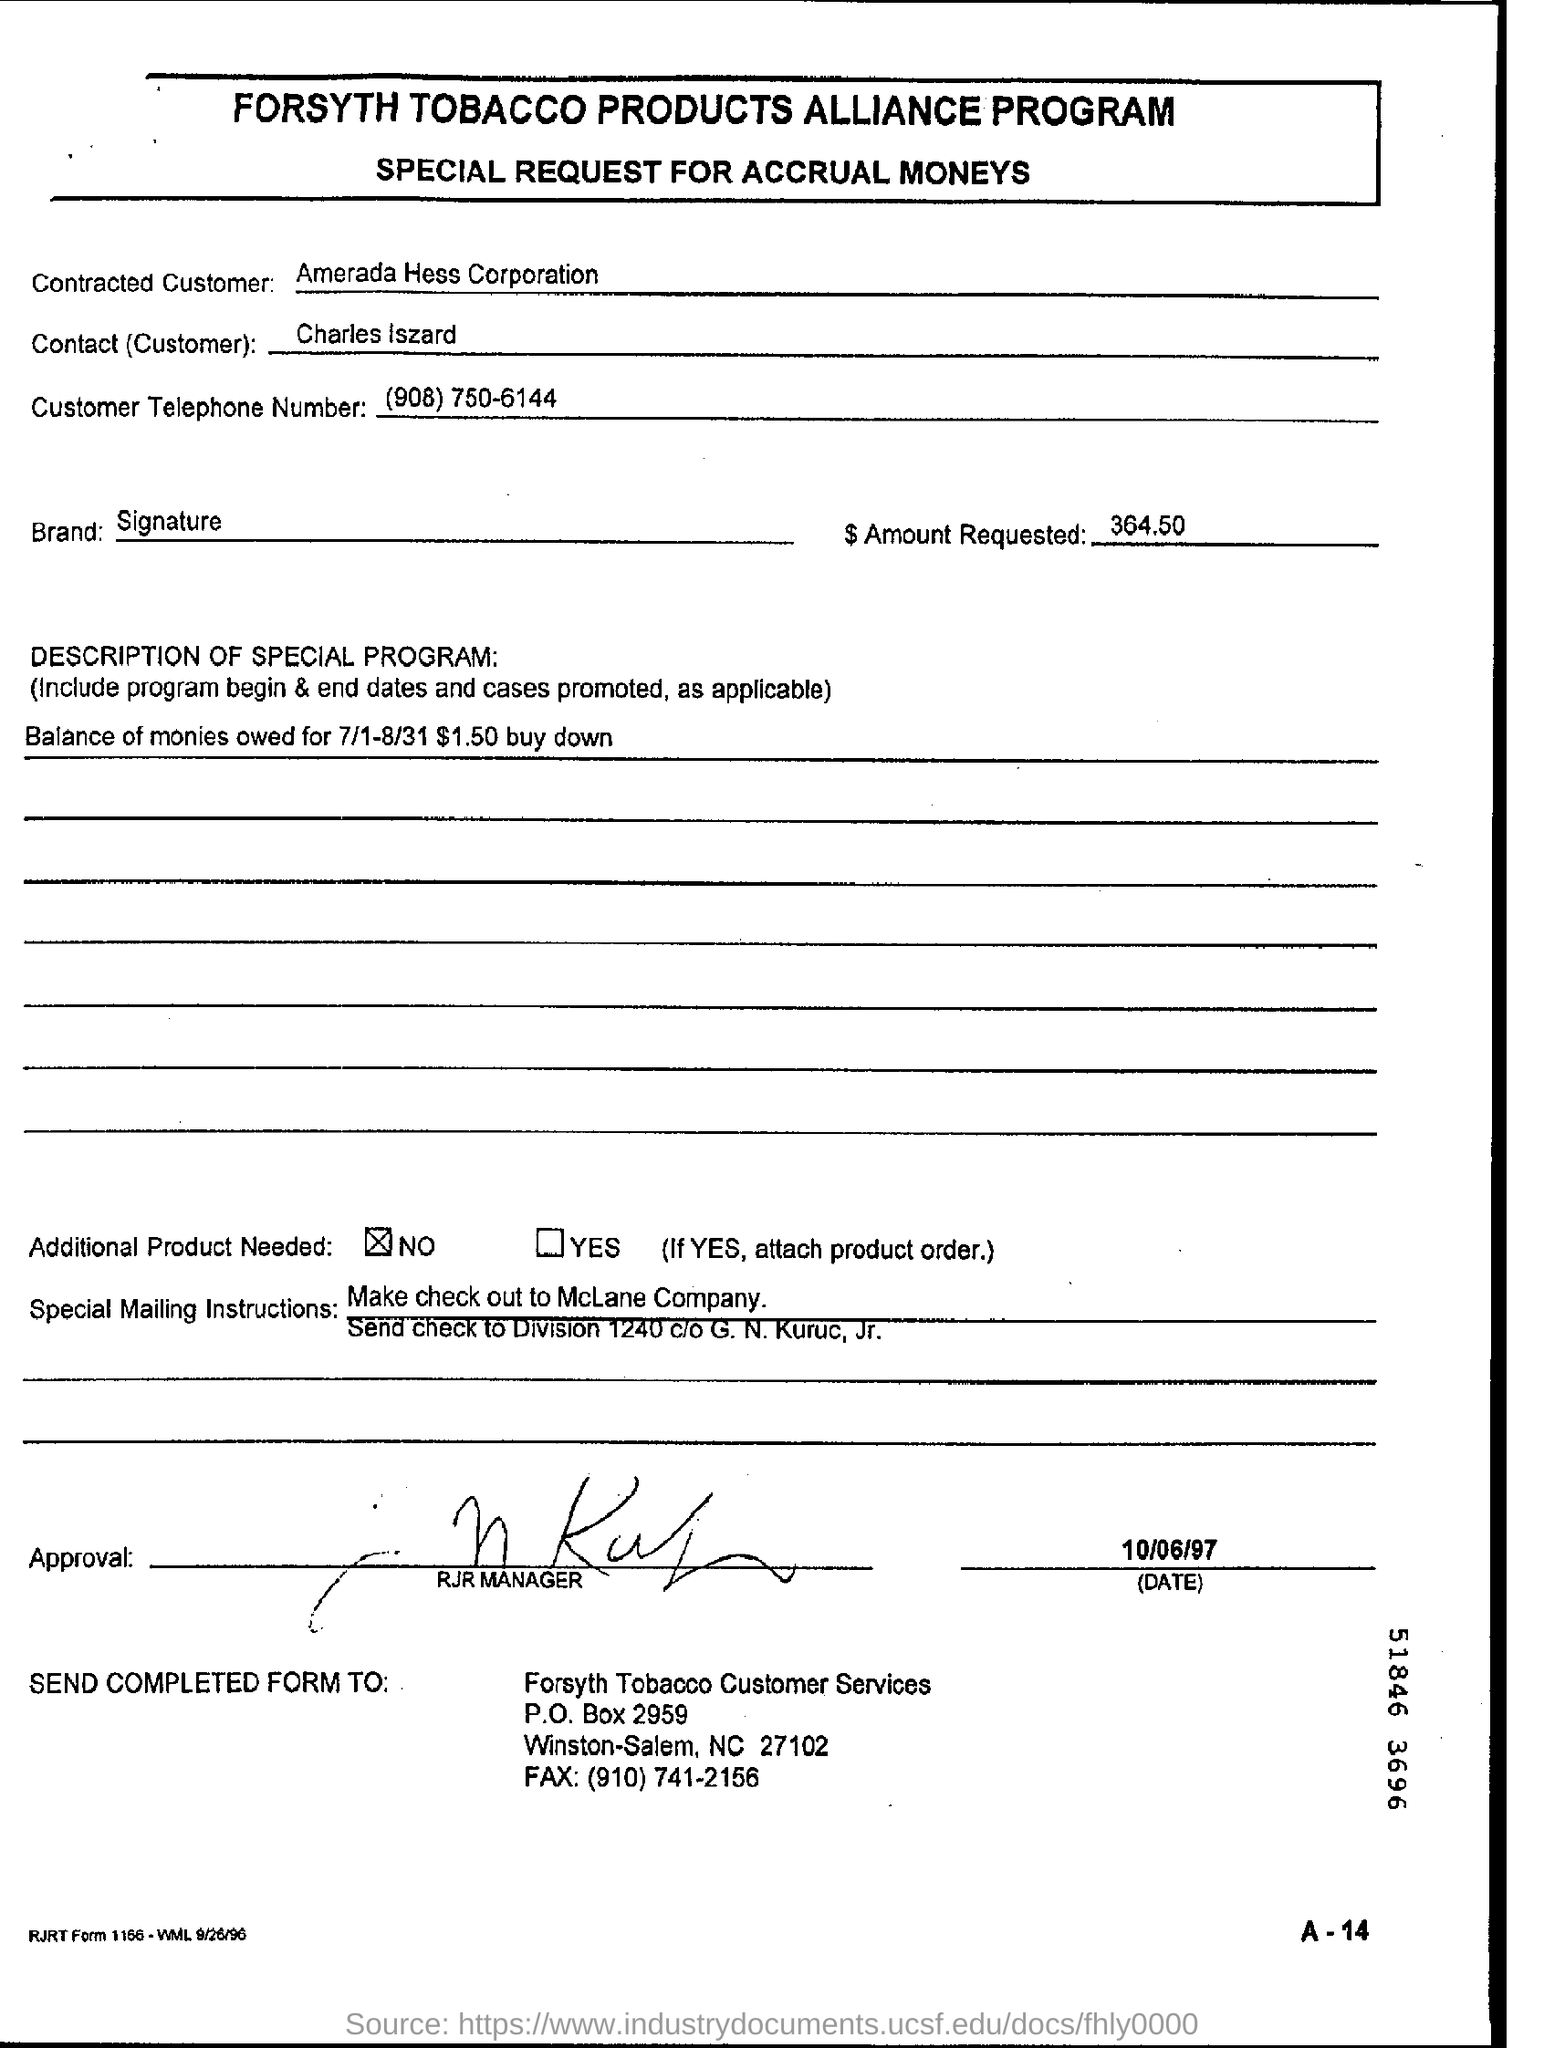Highlight a few significant elements in this photo. The customer's telephone number is (908) 750-6144. The contact person is Charles Iszard. What is the brand's signature? The customer who is contracted is Amerada Hess Corporation. 